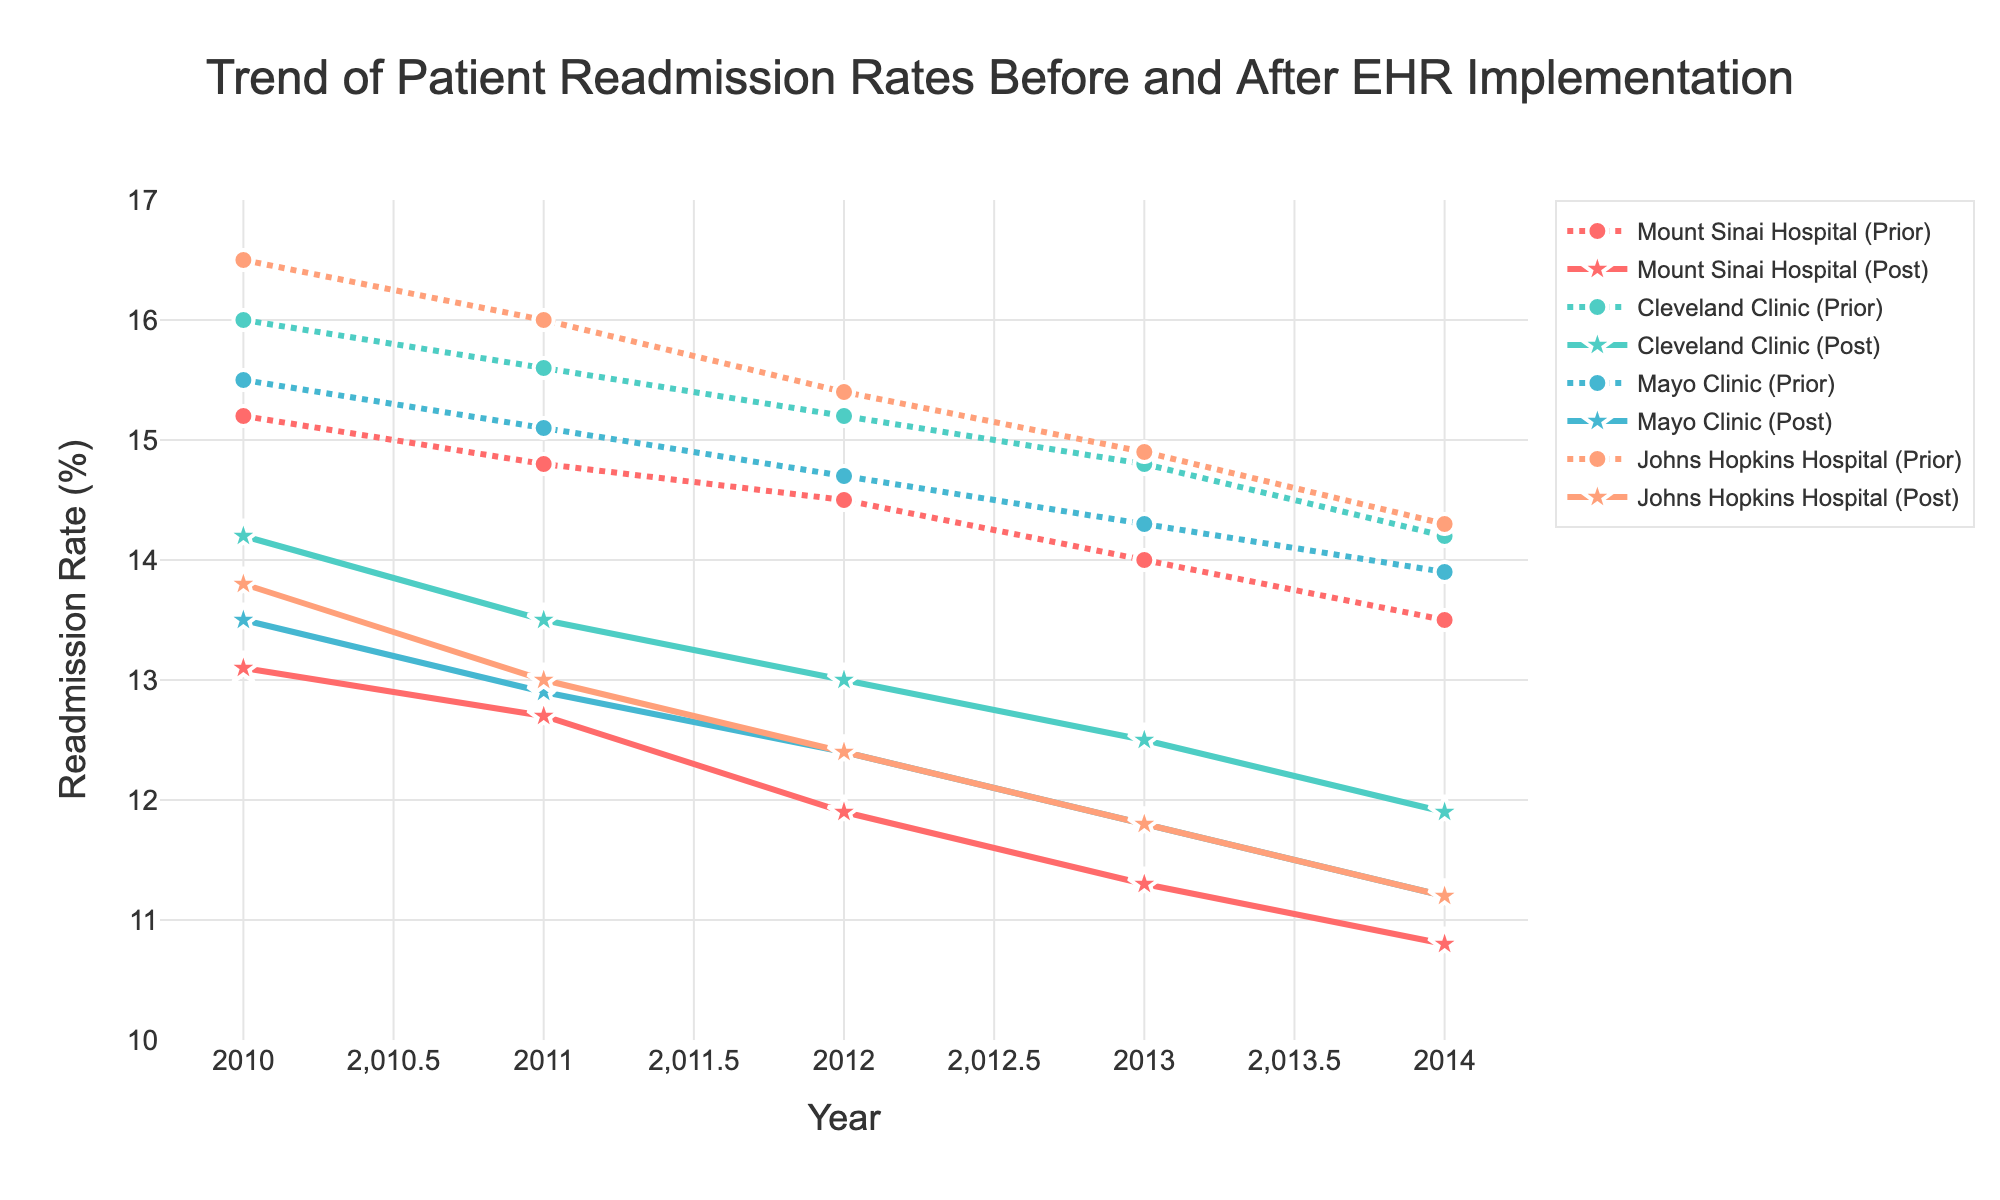What's the title of the figure? The title at the top of the figure reads "Trend of Patient Readmission Rates Before and After EHR Implementation," which summarizes the main focus of the plotted data.
Answer: Trend of Patient Readmission Rates Before and After EHR Implementation How many hospitals are included in the figure? The figure includes data for four hospitals, each represented by a different color and labeled in the legend.
Answer: Four Which year shows the lowest readmission rate for Mount Sinai Hospital after the implementation of EHR systems? Looking at the "Mount Sinai Hospital (Post)" line, the year 2014 shows the lowest readmission rate of 10.8%.
Answer: 2014 What is the range of readmission rates shown on the y-axis? The y-axis ranges from 10% to 17%, as indicated by the tick marks on the y-axis.
Answer: 10% - 17% Compare the readmission rates in 2013 for Cleveland Clinic before and after EHR implementation. What do you observe? The data point for Cleveland Clinic in 2013 shows a readmission rate of 14.8% before EHR implementation and 12.5% after. By subtracting 12.5 from 14.8, we see a reduction of 2.3 percentage points.
Answer: 2.3 percentage points reduction In which year did Mayo Clinic show the highest readmission rate before EHR implementation? By observing the Mayo Clinic (Prior) line, the highest readmission rate before EHR implementation is in 2010 at 15.5%.
Answer: 2010 What trend can be observed for the readmission rates at Johns Hopkins Hospital after EHR implementation over the years? From 2010 to 2014, Johns Hopkins Hospital's (Post) readmission rates have a clear decreasing trend, starting from 13.8% in 2010 down to 11.2% in 2014. Consistently, the yearly data points show a decline.
Answer: Decreasing Calculate the average readmission rate for Cleveland Clinic after EHR implementation over the displayed years. The post-implementation readmission rates for Cleveland Clinic are: 14.2%, 13.5%, 13.0%, 12.5%, 11.9%. The sum is 65.1, and there are 5 data points. So, the average is 65.1 / 5 = 13.02%.
Answer: 13.02% Which hospital had a relatively constant readmission rate before EHR implementation, and what was the general trend? Mount Sinai Hospital's readmission rates before EHR implementation (15.2%, 14.8%, 14.5%, 14.0%, 13.5%) show a consistent decreasing trend, as seen by a gradual decline each year.
Answer: Mount Sinai Hospital, decreasing trend 